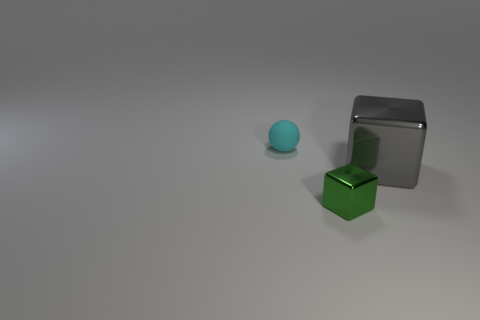What can you infer about the sizes of these objects in relation to each other? Based on the image, the blue sphere appears to be the smallest object. The green cube is medium-sized when compared to the other two. The gray matte cube seems to be the largest, both in height and in width.  Are there any shadows visible? What do they tell us about the lighting? Yes, there are shadows cast by each object, indicating that the light source is coming from the upper left. The lengths and directions of the shadows suggest a single light source, creating soft shadows, which gives the scene a calm, diffused lighting. 